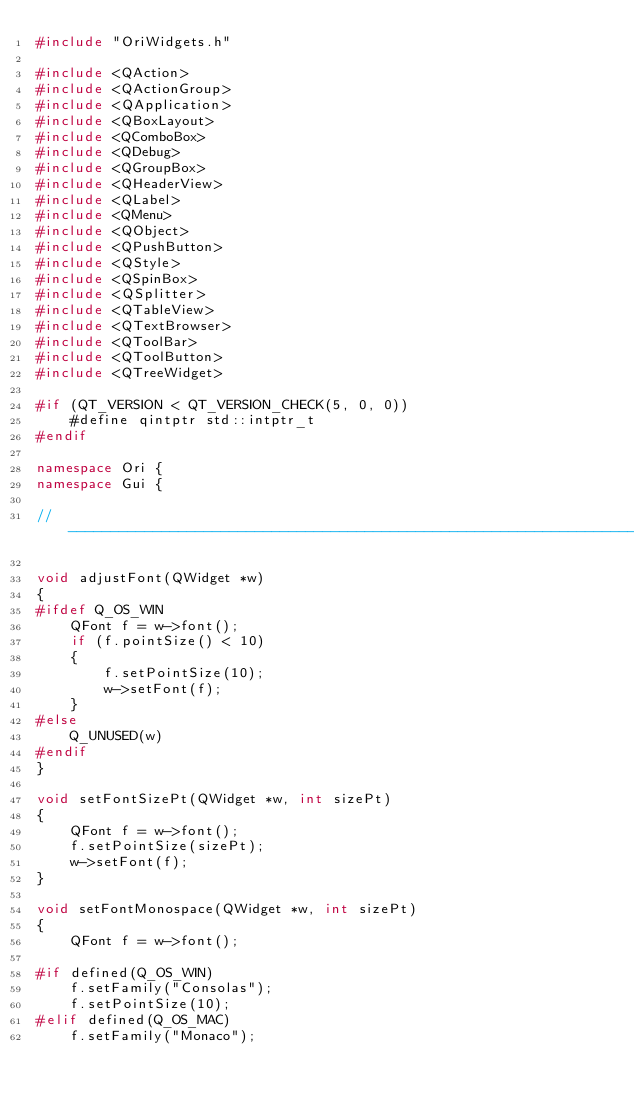Convert code to text. <code><loc_0><loc_0><loc_500><loc_500><_C++_>#include "OriWidgets.h"

#include <QAction>
#include <QActionGroup>
#include <QApplication>
#include <QBoxLayout>
#include <QComboBox>
#include <QDebug>
#include <QGroupBox>
#include <QHeaderView>
#include <QLabel>
#include <QMenu>
#include <QObject>
#include <QPushButton>
#include <QStyle>
#include <QSpinBox>
#include <QSplitter>
#include <QTableView>
#include <QTextBrowser>
#include <QToolBar>
#include <QToolButton>
#include <QTreeWidget>

#if (QT_VERSION < QT_VERSION_CHECK(5, 0, 0))
    #define qintptr std::intptr_t
#endif

namespace Ori {
namespace Gui {

//--------------------------------------------------------------------------------------------------

void adjustFont(QWidget *w)
{
#ifdef Q_OS_WIN
    QFont f = w->font();
    if (f.pointSize() < 10)
    {
        f.setPointSize(10);
        w->setFont(f);
    }
#else
    Q_UNUSED(w)
#endif
}

void setFontSizePt(QWidget *w, int sizePt)
{
    QFont f = w->font();
    f.setPointSize(sizePt);
    w->setFont(f);
}

void setFontMonospace(QWidget *w, int sizePt)
{
    QFont f = w->font();

#if defined(Q_OS_WIN)
    f.setFamily("Consolas");
    f.setPointSize(10);
#elif defined(Q_OS_MAC)
    f.setFamily("Monaco");</code> 